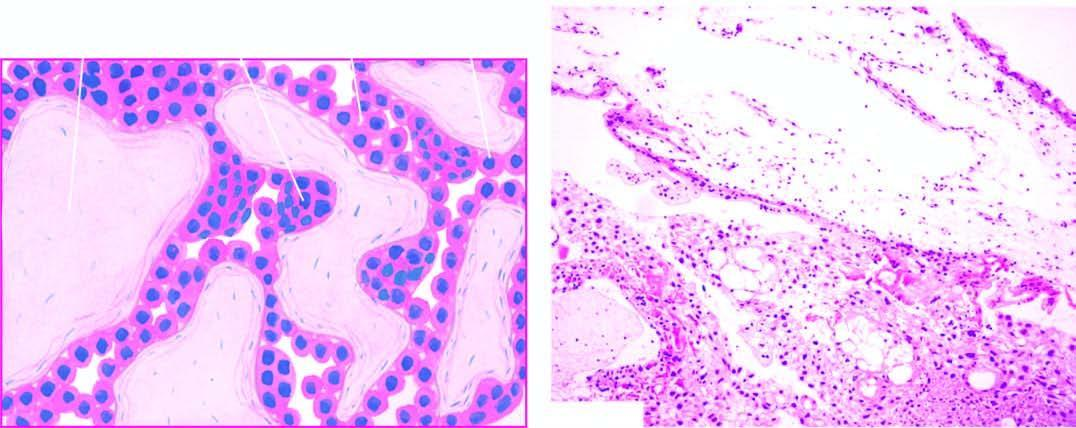what is characterised by hydropic and avascular enlarged villi with trophoblastic proliferation in the form of masses and sheets?
Answer the question using a single word or phrase. Hydatidiform mole 